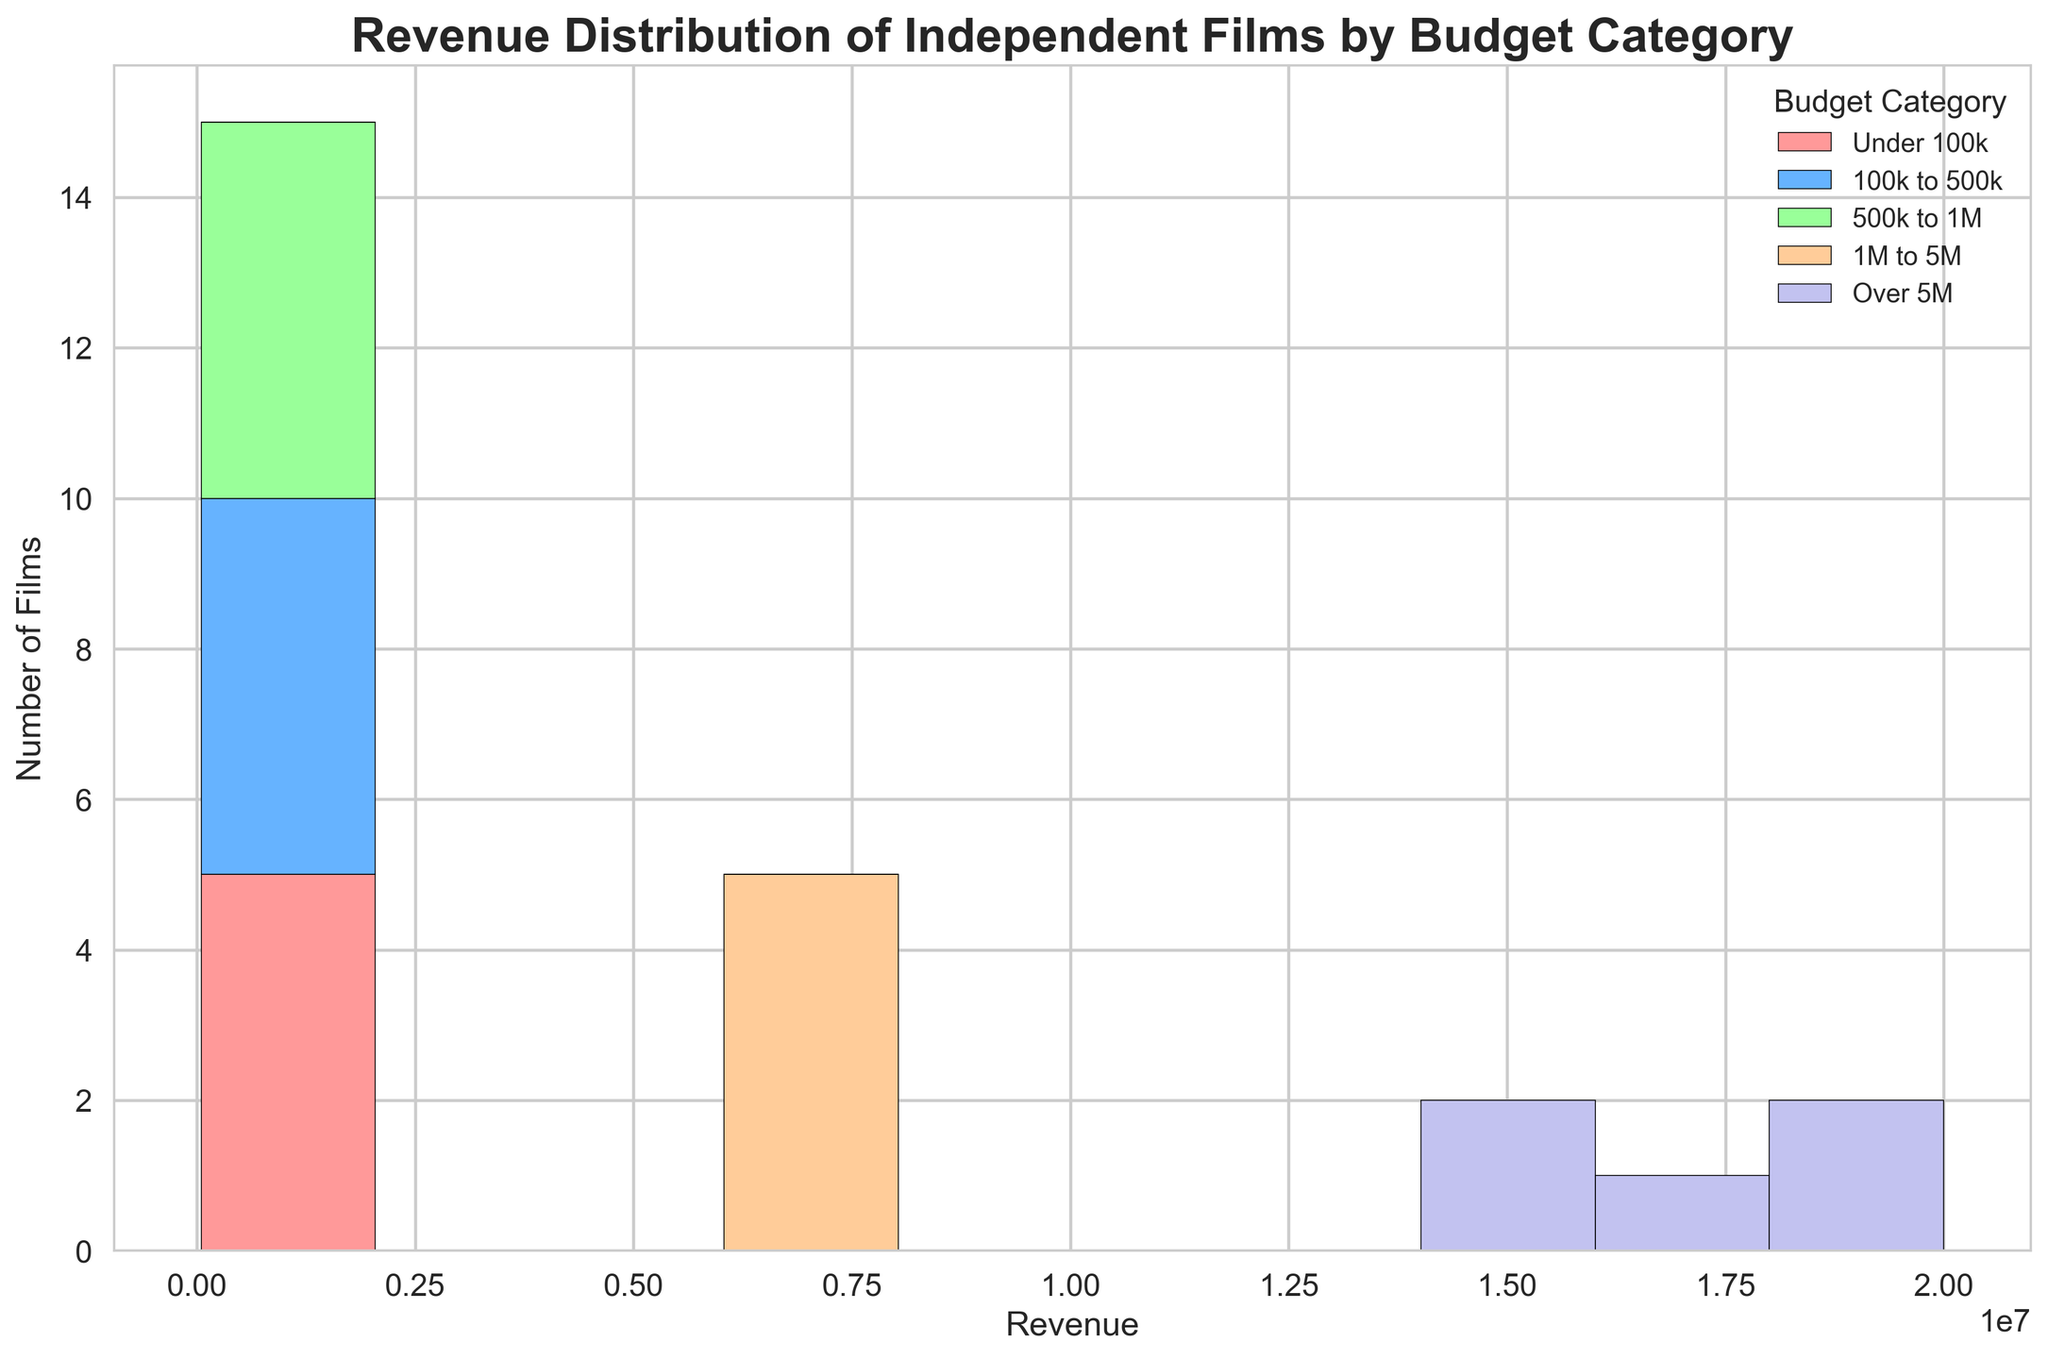What is the most common revenue range for independent films with a budget under 100k? By examining the tallest bar in the "Under 100k" budget category section, identify the revenue range it corresponds to.
Answer: The 50k to 100k range How does the frequency of films with a budget of 1M to 5M compare to those with a budget of 500k to 1M in terms of high revenue (greater than 7M)? Compare the number of bars representing films with revenue greater than 7M in both "1M to 5M" and "500k to 1M" categories.
Answer: More frequent in the 1M to 5M category What is the total number of films with a budget of 100k to 500k that made less than 400k revenue? Count the number of bars in the 100k to 500k category that fall under the revenue value of 400k.
Answer: 2 films Which budget category has the highest number of films with revenue exceeding 15M? Look at the "Over 5M" budget category specifically and count the bars with revenues above 15M; then compare with other categories.
Answer: Over 5M What budget category has the widest spread of revenue values? Visually identify the budget category with the widest range of revenue values from the lowest to the highest on the x-axis.
Answer: Over 5M Which category has the least number of films in the histogram? Identify the budget category with the fewest bars.
Answer: Under 100k Compare the highest revenue film in the "500k to 1M" category to the highest revenue film in the "1M to 5M" category. Which one is higher? Determine the top end of the revenue value represented by the highest bar in both categories and compare them.
Answer: The highest revenue film in "1M to 5M" is higher How many total budget categories are represented in the histogram? Count the distinct budget categories shown in the legend.
Answer: 5 categories What color represents the films with the budget category "Under 100k"? Refer to the legend and match the color associated with the "Under 100k" budget category.
Answer: Red 